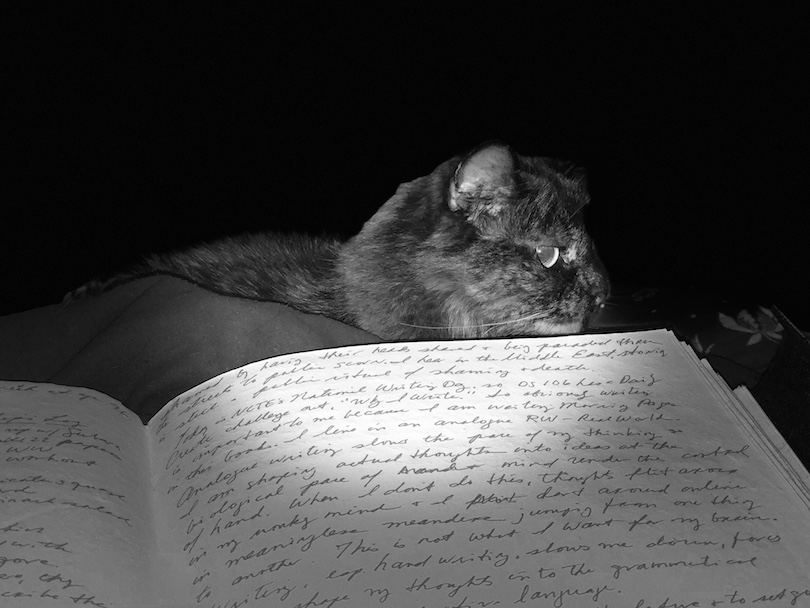Considering the lighting and reflections in the cat's eyes, what type of lighting conditions or photographic equipment was used to take the picture? The distinctive reflections in the cat's eyes, combined with the sharply delineated areas of light and darkness in this black and white photograph, suggest the utilization of a direct flash. This direct lighting approach not only serves to dramatically illuminate the subject at close range but also ensures that the background remains deeply shaded, thereby drawing the viewer's focus intensely onto the cat. The choice of black and white further amplifies this visual contrast, capturing depth, texture, and emotional tone of the scene through chiaroscuro effects, without the distraction of color. 